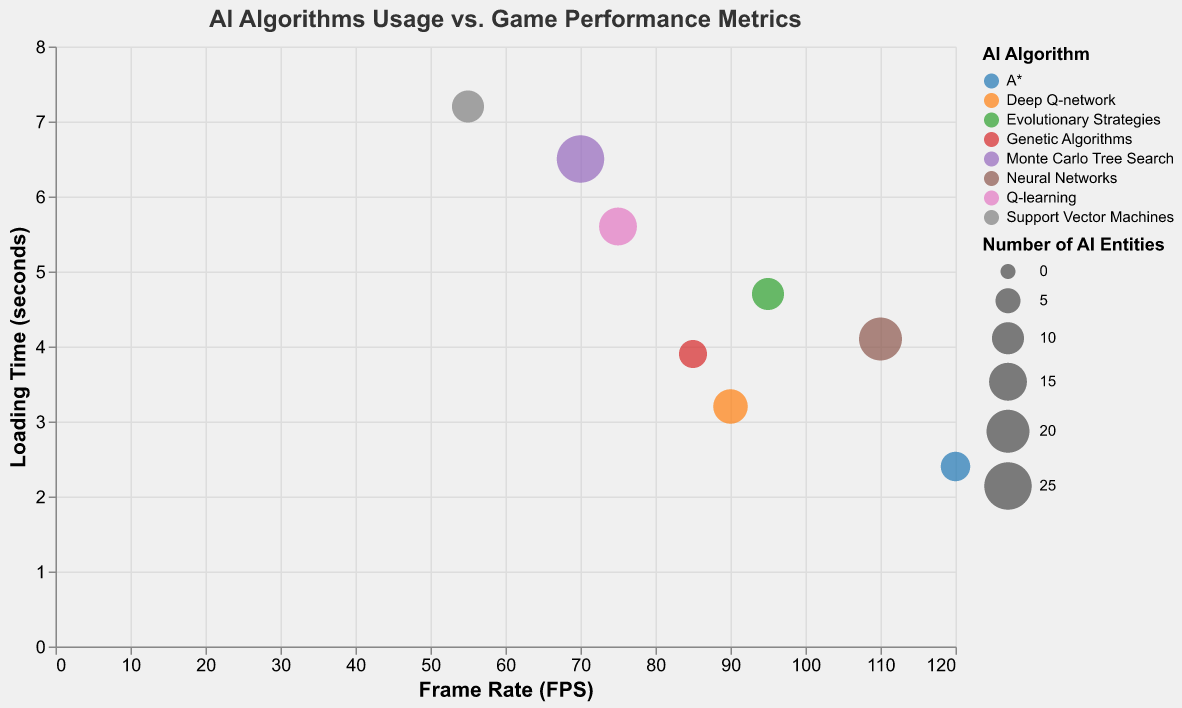How many different AI algorithms are represented in the chart? Count the unique categories under the "AI Algorithm" legend.
Answer: 8 Which game has the lowest frame rate? Identify the data point with the lowest x-axis value labeled "Frame Rate (FPS)".
Answer: Cyberpunk 2077 What is the loading time for FIFA 22? Hover over the bubble representing FIFA 22 in the tooltip and find the "Loading Time (s)".
Answer: 3.2 seconds Which game has the highest CPU usage percentage? Find the tooltip of each data point and look for the highest "CPU Usage (%)".
Answer: Cyberpunk 2077 Compare the frame rate and loading time between Doom Eternal and Age of Empires IV. Locate the data points for both games. Doom Eternal has a frame rate of 120 fps and loading time of 2.4 seconds. Age of Empires IV has a frame rate of 70 fps and loading time of 6.5 seconds.
Answer: Doom Eternal has higher frame rate with lower loading time What is the average frame rate of all games? Add all frame rate values and divide by the number of data points. The sum of frame rates is (120+75+90+110+85+70+55+95) = 700. There are 8 data points, so the average is 700/8.
Answer: 87.5 fps Which AI algorithm is associated with the game that has the most AI entities? Hover over the largest bubble to see which game has the most AI entities, which is Age of Empires IV with Monte Carlo Tree Search.
Answer: Monte Carlo Tree Search What is the relationship between the frame rate and loading time for the game with the fewest AI entities? The game with the fewest AI entities is Dark Souls III with Genetic Algorithms, having 7 AI entities, a frame rate of 85 fps, and a loading time of 3.9 seconds.
Answer: Frame rate is 85 fps and loading time is 3.9 seconds How does CPU usage percentage change with the number of AI entities? Compare the data points with varying sizes (representing number of AI entities) and look at their corresponding CPU usage values in the tooltips. Larger bubbles generally have higher CPU usage.
Answer: Generally, more AI entities result in higher CPU usage 